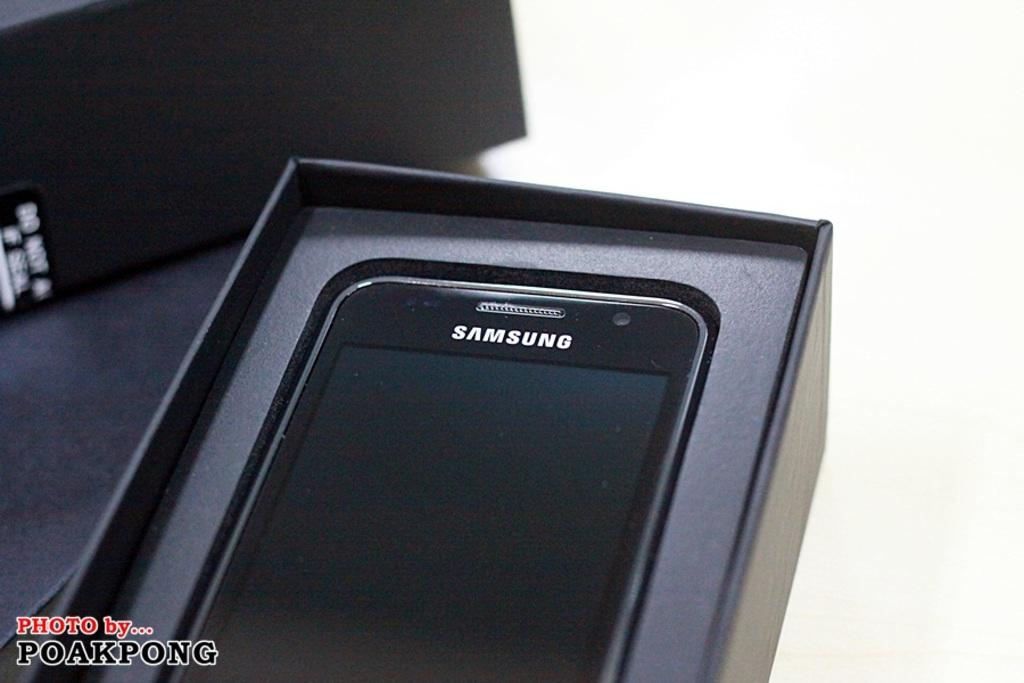Provide a one-sentence caption for the provided image. A Samsung phone sits in its box on a table. 